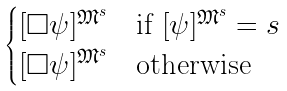Convert formula to latex. <formula><loc_0><loc_0><loc_500><loc_500>\begin{cases} [ \Box \psi ] ^ { \mathfrak { M } ^ { s } } & \text {if } [ \psi ] ^ { \mathfrak { M } ^ { s } } = s \\ [ \Box \psi ] ^ { \mathfrak { M } ^ { s } } & \text {otherwise} \end{cases}</formula> 